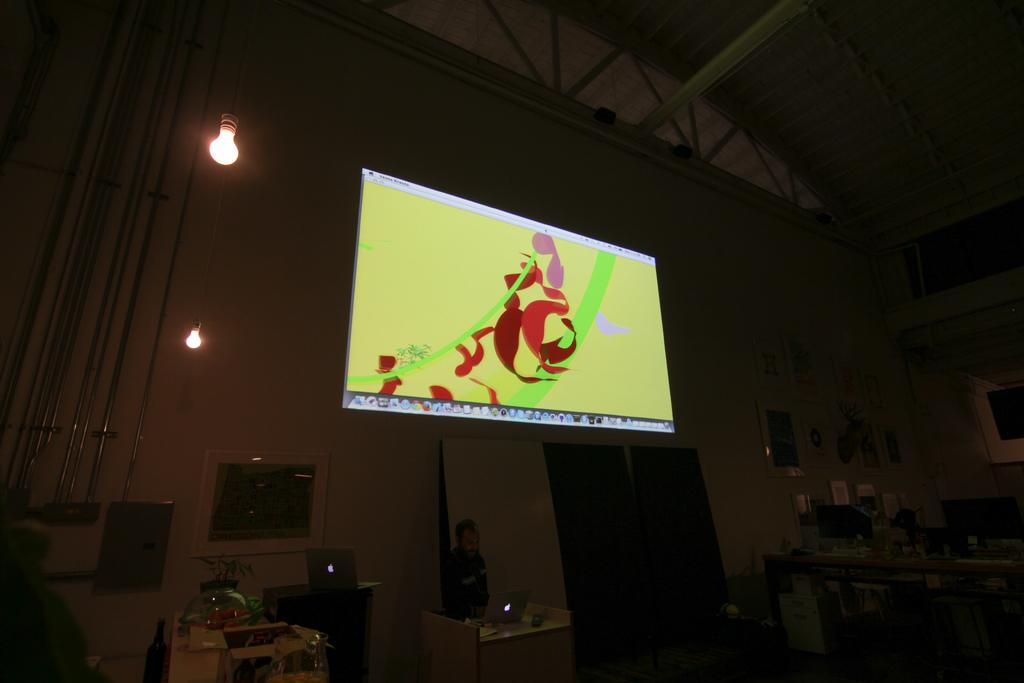What is the main object in the image? There is a screen in the image. What can be seen on the screen? The screen displays designs and icons. Are there any light sources visible in the image? Yes, there are lights visible in the image. What architectural feature can be seen in the image? There is a door in the image. What else can be observed in the image besides the screen and the door? There are other objects present in the image. How would you describe the overall lighting in the image? The image is slightly dark. How many cats are visible in the image? There are no cats present in the image. What type of slave is depicted in the image? There is no depiction of a slave in the image; it features a screen, lights, a door, and other objects. 